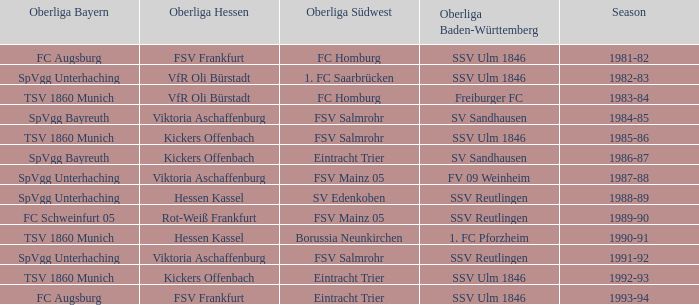Which oberliga baden-württemberg includes a 1991-92 term? SSV Reutlingen. 